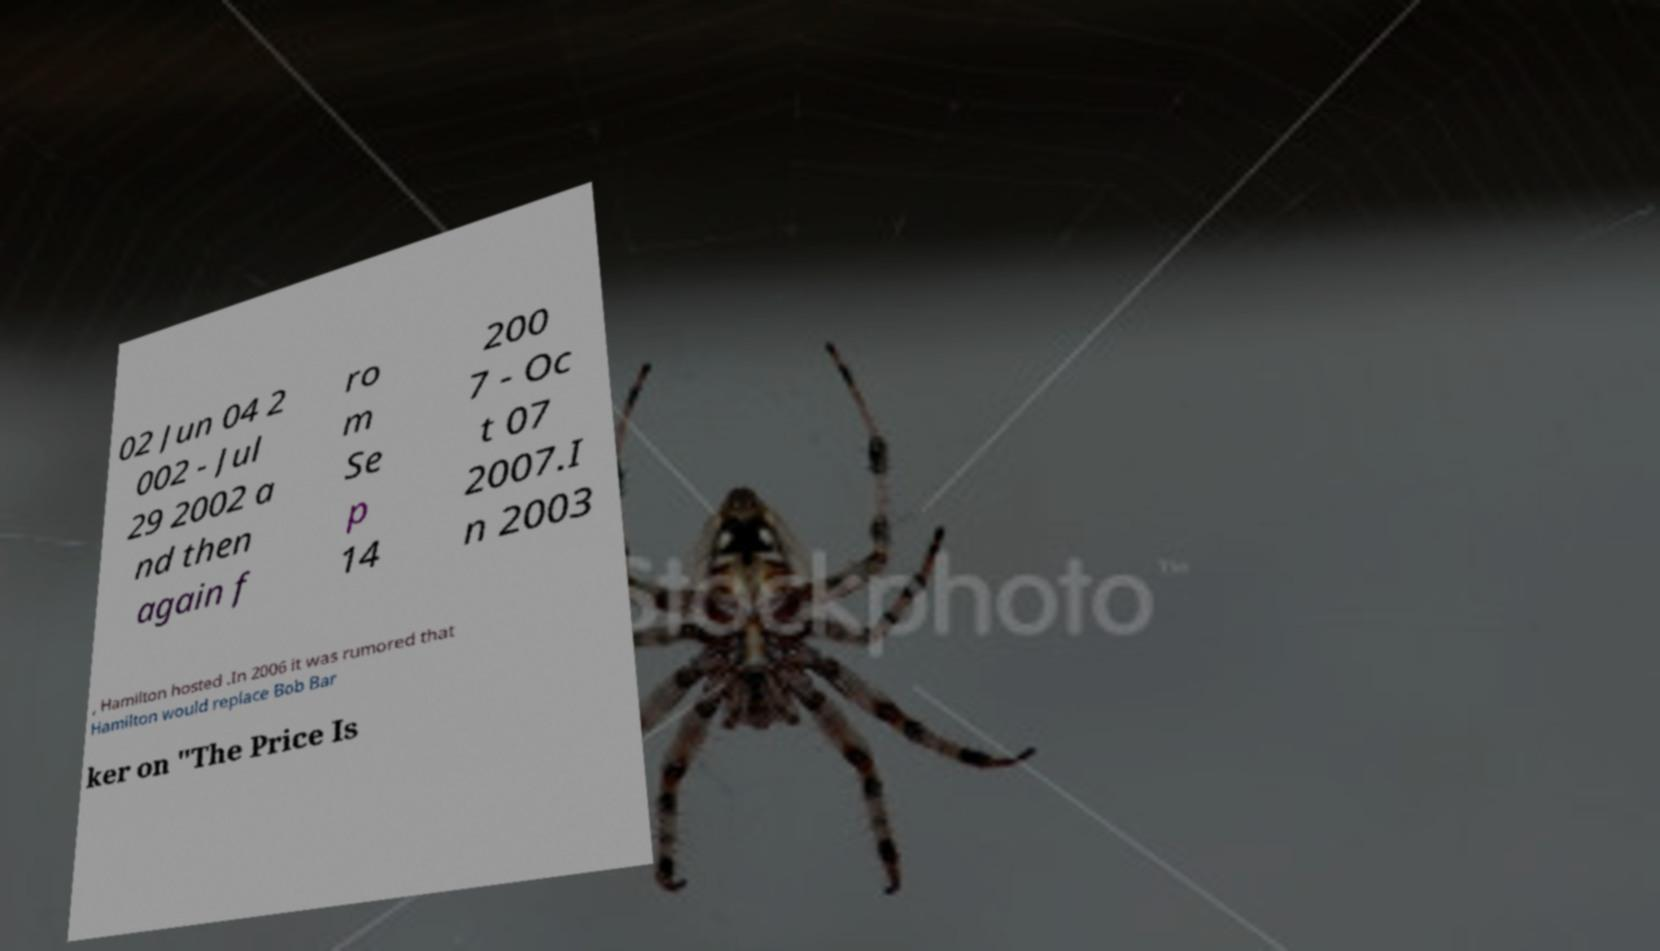Could you extract and type out the text from this image? 02 Jun 04 2 002 - Jul 29 2002 a nd then again f ro m Se p 14 200 7 - Oc t 07 2007.I n 2003 , Hamilton hosted .In 2006 it was rumored that Hamilton would replace Bob Bar ker on "The Price Is 